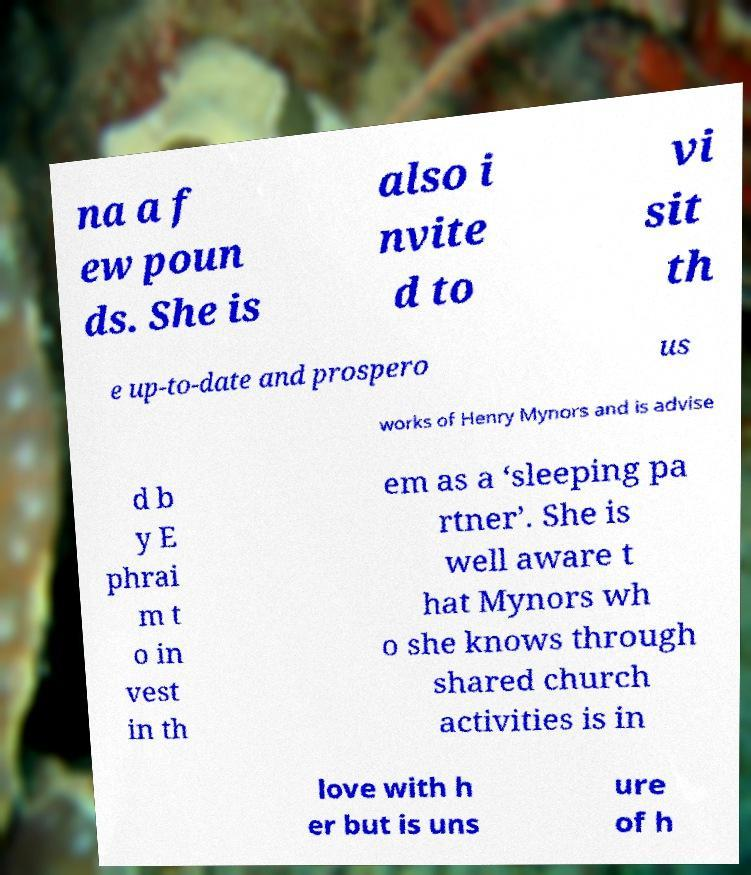Could you assist in decoding the text presented in this image and type it out clearly? na a f ew poun ds. She is also i nvite d to vi sit th e up-to-date and prospero us works of Henry Mynors and is advise d b y E phrai m t o in vest in th em as a ‘sleeping pa rtner’. She is well aware t hat Mynors wh o she knows through shared church activities is in love with h er but is uns ure of h 